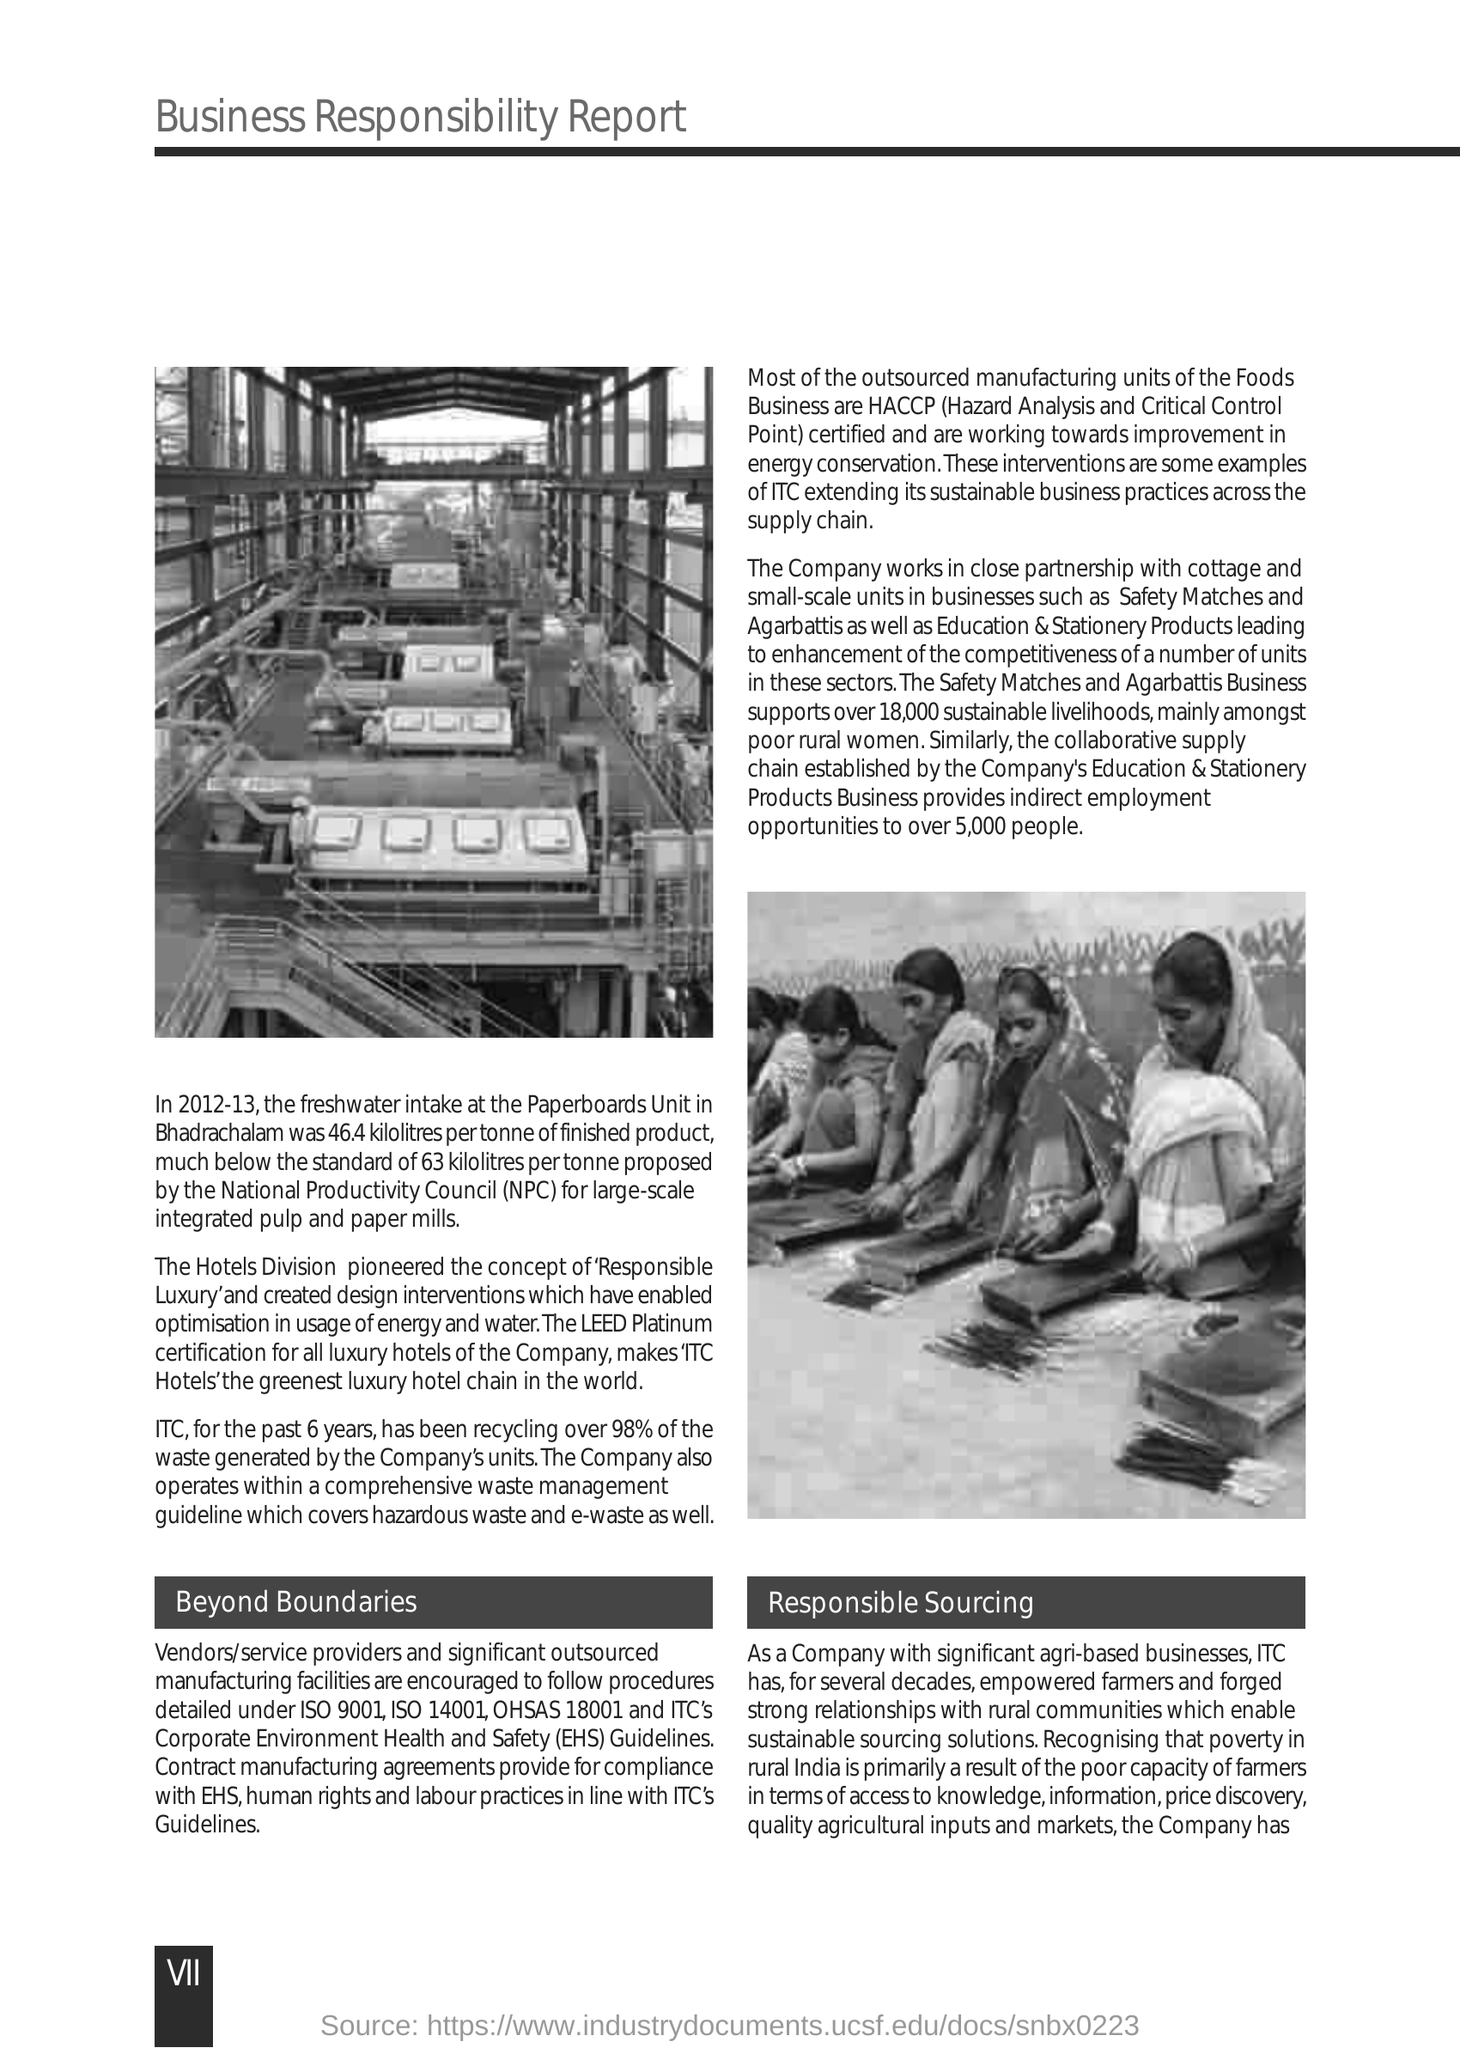What is recycling % of last 6 years of ITC?
Ensure brevity in your answer.  98%. 